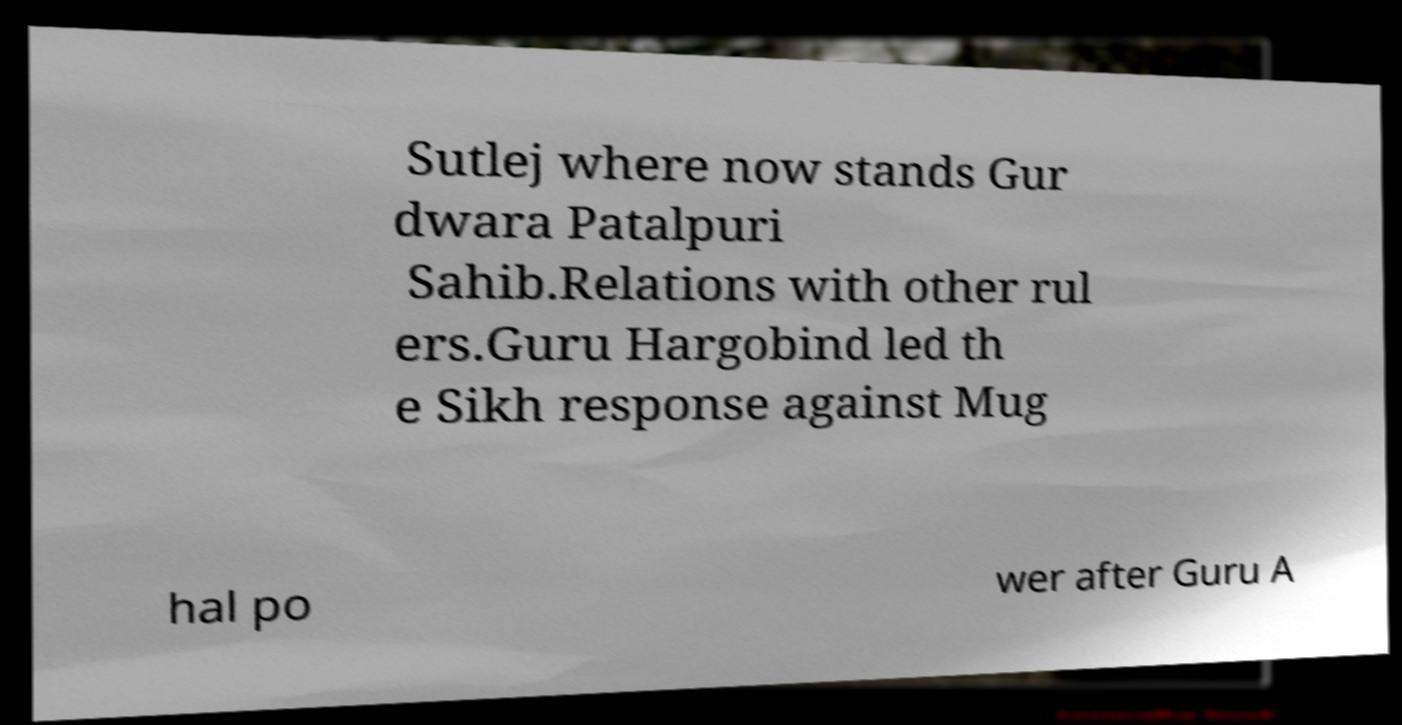Could you extract and type out the text from this image? Sutlej where now stands Gur dwara Patalpuri Sahib.Relations with other rul ers.Guru Hargobind led th e Sikh response against Mug hal po wer after Guru A 